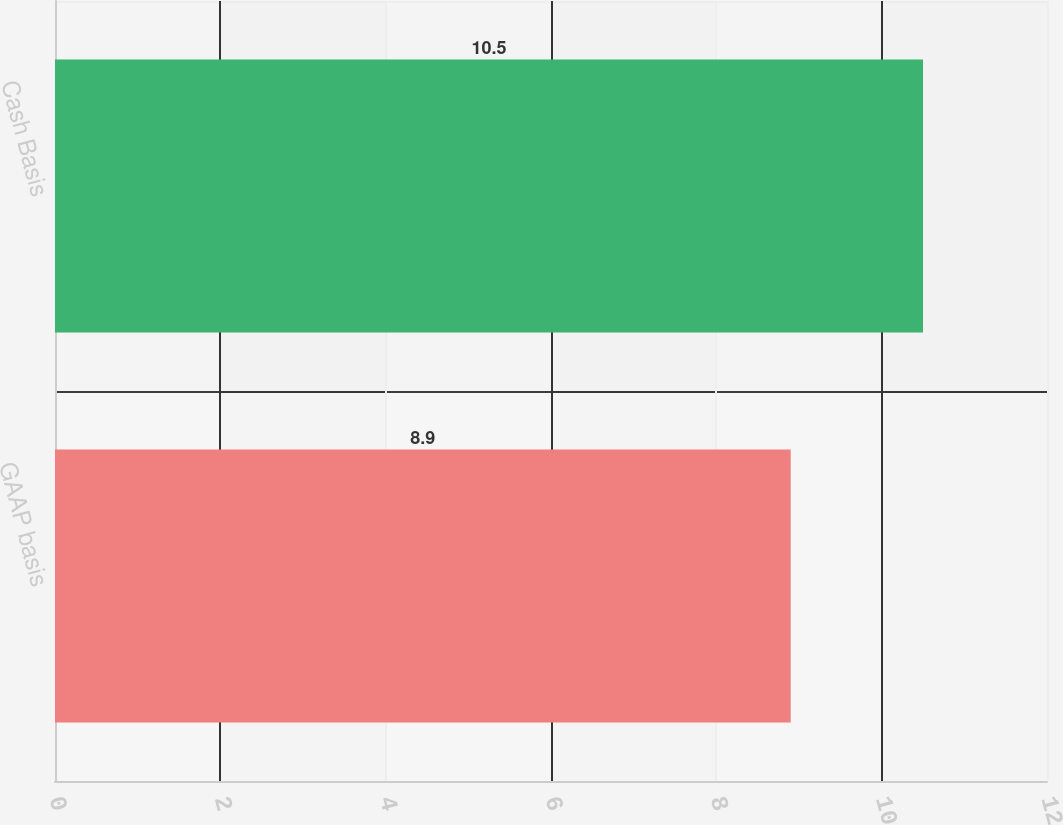Convert chart to OTSL. <chart><loc_0><loc_0><loc_500><loc_500><bar_chart><fcel>GAAP basis<fcel>Cash Basis<nl><fcel>8.9<fcel>10.5<nl></chart> 